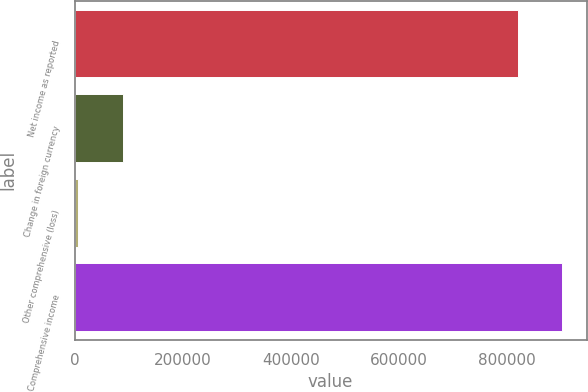Convert chart to OTSL. <chart><loc_0><loc_0><loc_500><loc_500><bar_chart><fcel>Net income as reported<fcel>Change in foreign currency<fcel>Other comprehensive (loss)<fcel>Comprehensive income<nl><fcel>820678<fcel>88657.8<fcel>6590<fcel>902746<nl></chart> 